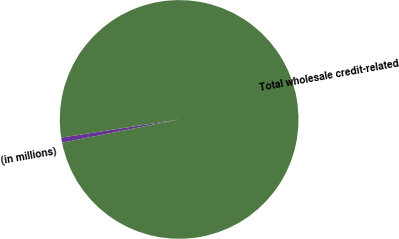Convert chart to OTSL. <chart><loc_0><loc_0><loc_500><loc_500><pie_chart><fcel>(in millions)<fcel>Total wholesale credit-related<nl><fcel>0.69%<fcel>99.31%<nl></chart> 